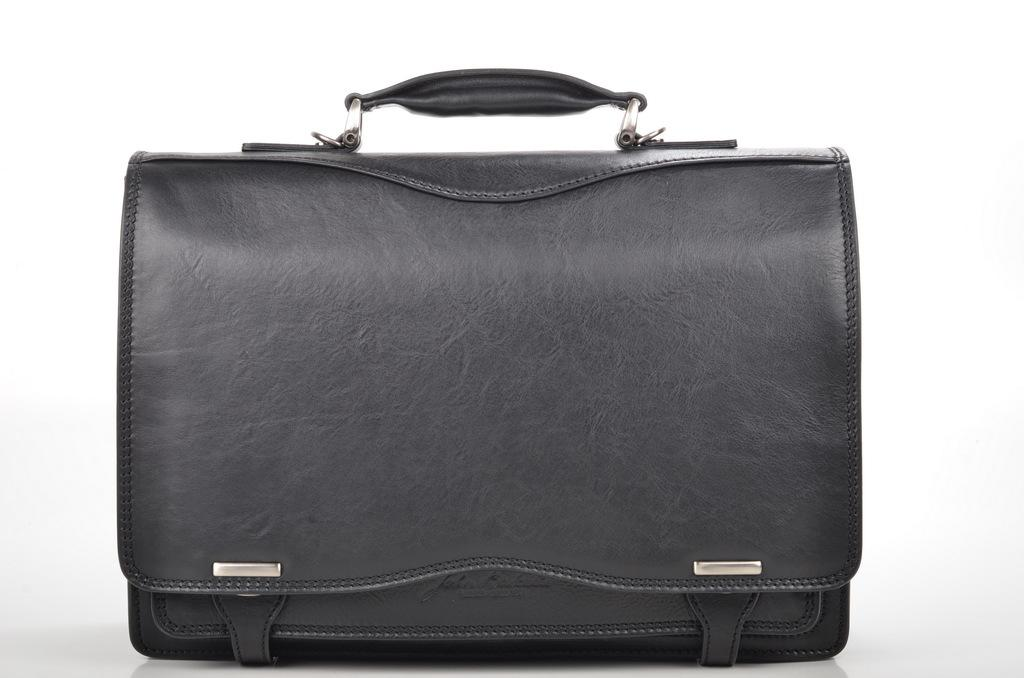What color is the bag that is visible in the image? There is a black color bag in the image. How many brothers are depicted in the image? There are no brothers present in the image; it only features a black color bag. Can you tell me if the bag is taking a breath in the image? The bag is an inanimate object and does not have the ability to breathe, so this question cannot be answered. 